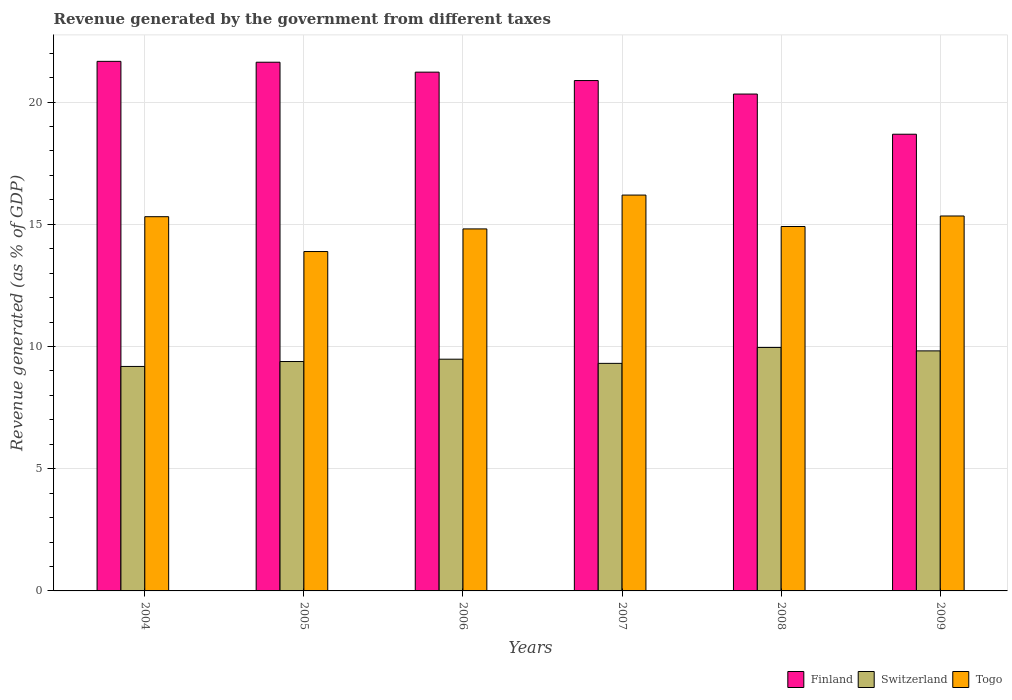How many different coloured bars are there?
Provide a short and direct response. 3. How many groups of bars are there?
Provide a short and direct response. 6. Are the number of bars per tick equal to the number of legend labels?
Your answer should be very brief. Yes. In how many cases, is the number of bars for a given year not equal to the number of legend labels?
Give a very brief answer. 0. What is the revenue generated by the government in Switzerland in 2008?
Offer a terse response. 9.96. Across all years, what is the maximum revenue generated by the government in Togo?
Make the answer very short. 16.2. Across all years, what is the minimum revenue generated by the government in Switzerland?
Your response must be concise. 9.18. What is the total revenue generated by the government in Togo in the graph?
Provide a succinct answer. 90.45. What is the difference between the revenue generated by the government in Togo in 2006 and that in 2009?
Make the answer very short. -0.53. What is the difference between the revenue generated by the government in Togo in 2007 and the revenue generated by the government in Finland in 2009?
Provide a short and direct response. -2.49. What is the average revenue generated by the government in Switzerland per year?
Provide a short and direct response. 9.52. In the year 2009, what is the difference between the revenue generated by the government in Finland and revenue generated by the government in Switzerland?
Ensure brevity in your answer.  8.86. What is the ratio of the revenue generated by the government in Togo in 2004 to that in 2006?
Offer a terse response. 1.03. Is the difference between the revenue generated by the government in Finland in 2008 and 2009 greater than the difference between the revenue generated by the government in Switzerland in 2008 and 2009?
Give a very brief answer. Yes. What is the difference between the highest and the second highest revenue generated by the government in Finland?
Give a very brief answer. 0.04. What is the difference between the highest and the lowest revenue generated by the government in Switzerland?
Give a very brief answer. 0.78. Is the sum of the revenue generated by the government in Togo in 2006 and 2007 greater than the maximum revenue generated by the government in Switzerland across all years?
Ensure brevity in your answer.  Yes. What does the 2nd bar from the left in 2004 represents?
Keep it short and to the point. Switzerland. What does the 1st bar from the right in 2007 represents?
Offer a very short reply. Togo. Are all the bars in the graph horizontal?
Offer a very short reply. No. Does the graph contain grids?
Keep it short and to the point. Yes. Where does the legend appear in the graph?
Your answer should be compact. Bottom right. How many legend labels are there?
Provide a short and direct response. 3. How are the legend labels stacked?
Keep it short and to the point. Horizontal. What is the title of the graph?
Your response must be concise. Revenue generated by the government from different taxes. What is the label or title of the X-axis?
Make the answer very short. Years. What is the label or title of the Y-axis?
Ensure brevity in your answer.  Revenue generated (as % of GDP). What is the Revenue generated (as % of GDP) of Finland in 2004?
Your response must be concise. 21.67. What is the Revenue generated (as % of GDP) in Switzerland in 2004?
Give a very brief answer. 9.18. What is the Revenue generated (as % of GDP) of Togo in 2004?
Offer a terse response. 15.31. What is the Revenue generated (as % of GDP) of Finland in 2005?
Give a very brief answer. 21.63. What is the Revenue generated (as % of GDP) in Switzerland in 2005?
Ensure brevity in your answer.  9.38. What is the Revenue generated (as % of GDP) in Togo in 2005?
Your response must be concise. 13.88. What is the Revenue generated (as % of GDP) in Finland in 2006?
Keep it short and to the point. 21.22. What is the Revenue generated (as % of GDP) of Switzerland in 2006?
Your response must be concise. 9.48. What is the Revenue generated (as % of GDP) in Togo in 2006?
Your answer should be compact. 14.81. What is the Revenue generated (as % of GDP) in Finland in 2007?
Offer a terse response. 20.88. What is the Revenue generated (as % of GDP) in Switzerland in 2007?
Ensure brevity in your answer.  9.31. What is the Revenue generated (as % of GDP) of Togo in 2007?
Provide a short and direct response. 16.2. What is the Revenue generated (as % of GDP) in Finland in 2008?
Keep it short and to the point. 20.33. What is the Revenue generated (as % of GDP) in Switzerland in 2008?
Your answer should be very brief. 9.96. What is the Revenue generated (as % of GDP) in Togo in 2008?
Ensure brevity in your answer.  14.91. What is the Revenue generated (as % of GDP) in Finland in 2009?
Make the answer very short. 18.68. What is the Revenue generated (as % of GDP) in Switzerland in 2009?
Your answer should be very brief. 9.82. What is the Revenue generated (as % of GDP) of Togo in 2009?
Your answer should be compact. 15.34. Across all years, what is the maximum Revenue generated (as % of GDP) in Finland?
Your response must be concise. 21.67. Across all years, what is the maximum Revenue generated (as % of GDP) of Switzerland?
Offer a very short reply. 9.96. Across all years, what is the maximum Revenue generated (as % of GDP) in Togo?
Provide a succinct answer. 16.2. Across all years, what is the minimum Revenue generated (as % of GDP) of Finland?
Keep it short and to the point. 18.68. Across all years, what is the minimum Revenue generated (as % of GDP) of Switzerland?
Offer a terse response. 9.18. Across all years, what is the minimum Revenue generated (as % of GDP) in Togo?
Provide a short and direct response. 13.88. What is the total Revenue generated (as % of GDP) in Finland in the graph?
Your response must be concise. 124.41. What is the total Revenue generated (as % of GDP) of Switzerland in the graph?
Provide a short and direct response. 57.14. What is the total Revenue generated (as % of GDP) of Togo in the graph?
Offer a very short reply. 90.45. What is the difference between the Revenue generated (as % of GDP) of Finland in 2004 and that in 2005?
Your answer should be compact. 0.04. What is the difference between the Revenue generated (as % of GDP) in Switzerland in 2004 and that in 2005?
Make the answer very short. -0.2. What is the difference between the Revenue generated (as % of GDP) in Togo in 2004 and that in 2005?
Provide a succinct answer. 1.43. What is the difference between the Revenue generated (as % of GDP) of Finland in 2004 and that in 2006?
Provide a short and direct response. 0.44. What is the difference between the Revenue generated (as % of GDP) in Switzerland in 2004 and that in 2006?
Your response must be concise. -0.3. What is the difference between the Revenue generated (as % of GDP) in Togo in 2004 and that in 2006?
Make the answer very short. 0.5. What is the difference between the Revenue generated (as % of GDP) in Finland in 2004 and that in 2007?
Your response must be concise. 0.79. What is the difference between the Revenue generated (as % of GDP) of Switzerland in 2004 and that in 2007?
Ensure brevity in your answer.  -0.13. What is the difference between the Revenue generated (as % of GDP) in Togo in 2004 and that in 2007?
Offer a terse response. -0.88. What is the difference between the Revenue generated (as % of GDP) of Finland in 2004 and that in 2008?
Make the answer very short. 1.34. What is the difference between the Revenue generated (as % of GDP) of Switzerland in 2004 and that in 2008?
Offer a terse response. -0.78. What is the difference between the Revenue generated (as % of GDP) of Togo in 2004 and that in 2008?
Provide a succinct answer. 0.4. What is the difference between the Revenue generated (as % of GDP) in Finland in 2004 and that in 2009?
Make the answer very short. 2.98. What is the difference between the Revenue generated (as % of GDP) of Switzerland in 2004 and that in 2009?
Give a very brief answer. -0.64. What is the difference between the Revenue generated (as % of GDP) of Togo in 2004 and that in 2009?
Make the answer very short. -0.03. What is the difference between the Revenue generated (as % of GDP) in Finland in 2005 and that in 2006?
Keep it short and to the point. 0.41. What is the difference between the Revenue generated (as % of GDP) in Switzerland in 2005 and that in 2006?
Your answer should be compact. -0.1. What is the difference between the Revenue generated (as % of GDP) of Togo in 2005 and that in 2006?
Offer a very short reply. -0.93. What is the difference between the Revenue generated (as % of GDP) of Finland in 2005 and that in 2007?
Provide a succinct answer. 0.75. What is the difference between the Revenue generated (as % of GDP) in Switzerland in 2005 and that in 2007?
Ensure brevity in your answer.  0.08. What is the difference between the Revenue generated (as % of GDP) of Togo in 2005 and that in 2007?
Your answer should be very brief. -2.31. What is the difference between the Revenue generated (as % of GDP) in Finland in 2005 and that in 2008?
Make the answer very short. 1.3. What is the difference between the Revenue generated (as % of GDP) in Switzerland in 2005 and that in 2008?
Keep it short and to the point. -0.58. What is the difference between the Revenue generated (as % of GDP) in Togo in 2005 and that in 2008?
Your answer should be very brief. -1.02. What is the difference between the Revenue generated (as % of GDP) in Finland in 2005 and that in 2009?
Your answer should be very brief. 2.95. What is the difference between the Revenue generated (as % of GDP) in Switzerland in 2005 and that in 2009?
Ensure brevity in your answer.  -0.44. What is the difference between the Revenue generated (as % of GDP) of Togo in 2005 and that in 2009?
Offer a very short reply. -1.45. What is the difference between the Revenue generated (as % of GDP) of Finland in 2006 and that in 2007?
Offer a very short reply. 0.34. What is the difference between the Revenue generated (as % of GDP) of Switzerland in 2006 and that in 2007?
Ensure brevity in your answer.  0.17. What is the difference between the Revenue generated (as % of GDP) in Togo in 2006 and that in 2007?
Provide a succinct answer. -1.38. What is the difference between the Revenue generated (as % of GDP) of Finland in 2006 and that in 2008?
Keep it short and to the point. 0.9. What is the difference between the Revenue generated (as % of GDP) of Switzerland in 2006 and that in 2008?
Your answer should be compact. -0.48. What is the difference between the Revenue generated (as % of GDP) in Togo in 2006 and that in 2008?
Provide a succinct answer. -0.1. What is the difference between the Revenue generated (as % of GDP) of Finland in 2006 and that in 2009?
Offer a terse response. 2.54. What is the difference between the Revenue generated (as % of GDP) in Switzerland in 2006 and that in 2009?
Keep it short and to the point. -0.34. What is the difference between the Revenue generated (as % of GDP) in Togo in 2006 and that in 2009?
Offer a very short reply. -0.53. What is the difference between the Revenue generated (as % of GDP) in Finland in 2007 and that in 2008?
Provide a short and direct response. 0.55. What is the difference between the Revenue generated (as % of GDP) of Switzerland in 2007 and that in 2008?
Your response must be concise. -0.65. What is the difference between the Revenue generated (as % of GDP) in Togo in 2007 and that in 2008?
Provide a short and direct response. 1.29. What is the difference between the Revenue generated (as % of GDP) of Finland in 2007 and that in 2009?
Your response must be concise. 2.2. What is the difference between the Revenue generated (as % of GDP) of Switzerland in 2007 and that in 2009?
Provide a succinct answer. -0.51. What is the difference between the Revenue generated (as % of GDP) in Togo in 2007 and that in 2009?
Offer a terse response. 0.86. What is the difference between the Revenue generated (as % of GDP) of Finland in 2008 and that in 2009?
Give a very brief answer. 1.64. What is the difference between the Revenue generated (as % of GDP) of Switzerland in 2008 and that in 2009?
Provide a short and direct response. 0.14. What is the difference between the Revenue generated (as % of GDP) in Togo in 2008 and that in 2009?
Ensure brevity in your answer.  -0.43. What is the difference between the Revenue generated (as % of GDP) of Finland in 2004 and the Revenue generated (as % of GDP) of Switzerland in 2005?
Ensure brevity in your answer.  12.28. What is the difference between the Revenue generated (as % of GDP) of Finland in 2004 and the Revenue generated (as % of GDP) of Togo in 2005?
Provide a succinct answer. 7.78. What is the difference between the Revenue generated (as % of GDP) of Switzerland in 2004 and the Revenue generated (as % of GDP) of Togo in 2005?
Offer a very short reply. -4.7. What is the difference between the Revenue generated (as % of GDP) in Finland in 2004 and the Revenue generated (as % of GDP) in Switzerland in 2006?
Ensure brevity in your answer.  12.19. What is the difference between the Revenue generated (as % of GDP) of Finland in 2004 and the Revenue generated (as % of GDP) of Togo in 2006?
Provide a succinct answer. 6.86. What is the difference between the Revenue generated (as % of GDP) in Switzerland in 2004 and the Revenue generated (as % of GDP) in Togo in 2006?
Make the answer very short. -5.63. What is the difference between the Revenue generated (as % of GDP) of Finland in 2004 and the Revenue generated (as % of GDP) of Switzerland in 2007?
Give a very brief answer. 12.36. What is the difference between the Revenue generated (as % of GDP) of Finland in 2004 and the Revenue generated (as % of GDP) of Togo in 2007?
Your answer should be very brief. 5.47. What is the difference between the Revenue generated (as % of GDP) in Switzerland in 2004 and the Revenue generated (as % of GDP) in Togo in 2007?
Offer a terse response. -7.01. What is the difference between the Revenue generated (as % of GDP) of Finland in 2004 and the Revenue generated (as % of GDP) of Switzerland in 2008?
Offer a very short reply. 11.71. What is the difference between the Revenue generated (as % of GDP) in Finland in 2004 and the Revenue generated (as % of GDP) in Togo in 2008?
Provide a succinct answer. 6.76. What is the difference between the Revenue generated (as % of GDP) in Switzerland in 2004 and the Revenue generated (as % of GDP) in Togo in 2008?
Provide a short and direct response. -5.72. What is the difference between the Revenue generated (as % of GDP) of Finland in 2004 and the Revenue generated (as % of GDP) of Switzerland in 2009?
Your response must be concise. 11.85. What is the difference between the Revenue generated (as % of GDP) in Finland in 2004 and the Revenue generated (as % of GDP) in Togo in 2009?
Your answer should be compact. 6.33. What is the difference between the Revenue generated (as % of GDP) of Switzerland in 2004 and the Revenue generated (as % of GDP) of Togo in 2009?
Offer a terse response. -6.15. What is the difference between the Revenue generated (as % of GDP) in Finland in 2005 and the Revenue generated (as % of GDP) in Switzerland in 2006?
Your answer should be compact. 12.15. What is the difference between the Revenue generated (as % of GDP) of Finland in 2005 and the Revenue generated (as % of GDP) of Togo in 2006?
Your answer should be compact. 6.82. What is the difference between the Revenue generated (as % of GDP) of Switzerland in 2005 and the Revenue generated (as % of GDP) of Togo in 2006?
Provide a short and direct response. -5.43. What is the difference between the Revenue generated (as % of GDP) of Finland in 2005 and the Revenue generated (as % of GDP) of Switzerland in 2007?
Make the answer very short. 12.32. What is the difference between the Revenue generated (as % of GDP) in Finland in 2005 and the Revenue generated (as % of GDP) in Togo in 2007?
Your answer should be compact. 5.43. What is the difference between the Revenue generated (as % of GDP) in Switzerland in 2005 and the Revenue generated (as % of GDP) in Togo in 2007?
Provide a short and direct response. -6.81. What is the difference between the Revenue generated (as % of GDP) of Finland in 2005 and the Revenue generated (as % of GDP) of Switzerland in 2008?
Offer a terse response. 11.67. What is the difference between the Revenue generated (as % of GDP) in Finland in 2005 and the Revenue generated (as % of GDP) in Togo in 2008?
Your answer should be compact. 6.72. What is the difference between the Revenue generated (as % of GDP) of Switzerland in 2005 and the Revenue generated (as % of GDP) of Togo in 2008?
Provide a succinct answer. -5.52. What is the difference between the Revenue generated (as % of GDP) in Finland in 2005 and the Revenue generated (as % of GDP) in Switzerland in 2009?
Ensure brevity in your answer.  11.81. What is the difference between the Revenue generated (as % of GDP) in Finland in 2005 and the Revenue generated (as % of GDP) in Togo in 2009?
Your answer should be compact. 6.29. What is the difference between the Revenue generated (as % of GDP) of Switzerland in 2005 and the Revenue generated (as % of GDP) of Togo in 2009?
Your answer should be compact. -5.95. What is the difference between the Revenue generated (as % of GDP) in Finland in 2006 and the Revenue generated (as % of GDP) in Switzerland in 2007?
Your answer should be compact. 11.91. What is the difference between the Revenue generated (as % of GDP) of Finland in 2006 and the Revenue generated (as % of GDP) of Togo in 2007?
Offer a very short reply. 5.03. What is the difference between the Revenue generated (as % of GDP) in Switzerland in 2006 and the Revenue generated (as % of GDP) in Togo in 2007?
Keep it short and to the point. -6.71. What is the difference between the Revenue generated (as % of GDP) in Finland in 2006 and the Revenue generated (as % of GDP) in Switzerland in 2008?
Offer a terse response. 11.26. What is the difference between the Revenue generated (as % of GDP) in Finland in 2006 and the Revenue generated (as % of GDP) in Togo in 2008?
Your answer should be compact. 6.32. What is the difference between the Revenue generated (as % of GDP) of Switzerland in 2006 and the Revenue generated (as % of GDP) of Togo in 2008?
Offer a very short reply. -5.43. What is the difference between the Revenue generated (as % of GDP) of Finland in 2006 and the Revenue generated (as % of GDP) of Switzerland in 2009?
Give a very brief answer. 11.4. What is the difference between the Revenue generated (as % of GDP) in Finland in 2006 and the Revenue generated (as % of GDP) in Togo in 2009?
Offer a very short reply. 5.89. What is the difference between the Revenue generated (as % of GDP) in Switzerland in 2006 and the Revenue generated (as % of GDP) in Togo in 2009?
Your answer should be compact. -5.86. What is the difference between the Revenue generated (as % of GDP) of Finland in 2007 and the Revenue generated (as % of GDP) of Switzerland in 2008?
Your response must be concise. 10.92. What is the difference between the Revenue generated (as % of GDP) of Finland in 2007 and the Revenue generated (as % of GDP) of Togo in 2008?
Make the answer very short. 5.97. What is the difference between the Revenue generated (as % of GDP) in Switzerland in 2007 and the Revenue generated (as % of GDP) in Togo in 2008?
Your answer should be compact. -5.6. What is the difference between the Revenue generated (as % of GDP) in Finland in 2007 and the Revenue generated (as % of GDP) in Switzerland in 2009?
Offer a very short reply. 11.06. What is the difference between the Revenue generated (as % of GDP) of Finland in 2007 and the Revenue generated (as % of GDP) of Togo in 2009?
Your answer should be compact. 5.54. What is the difference between the Revenue generated (as % of GDP) of Switzerland in 2007 and the Revenue generated (as % of GDP) of Togo in 2009?
Your answer should be compact. -6.03. What is the difference between the Revenue generated (as % of GDP) of Finland in 2008 and the Revenue generated (as % of GDP) of Switzerland in 2009?
Your answer should be compact. 10.51. What is the difference between the Revenue generated (as % of GDP) of Finland in 2008 and the Revenue generated (as % of GDP) of Togo in 2009?
Give a very brief answer. 4.99. What is the difference between the Revenue generated (as % of GDP) in Switzerland in 2008 and the Revenue generated (as % of GDP) in Togo in 2009?
Keep it short and to the point. -5.38. What is the average Revenue generated (as % of GDP) in Finland per year?
Provide a short and direct response. 20.74. What is the average Revenue generated (as % of GDP) in Switzerland per year?
Ensure brevity in your answer.  9.52. What is the average Revenue generated (as % of GDP) of Togo per year?
Your answer should be very brief. 15.07. In the year 2004, what is the difference between the Revenue generated (as % of GDP) in Finland and Revenue generated (as % of GDP) in Switzerland?
Provide a succinct answer. 12.48. In the year 2004, what is the difference between the Revenue generated (as % of GDP) of Finland and Revenue generated (as % of GDP) of Togo?
Keep it short and to the point. 6.36. In the year 2004, what is the difference between the Revenue generated (as % of GDP) of Switzerland and Revenue generated (as % of GDP) of Togo?
Offer a terse response. -6.13. In the year 2005, what is the difference between the Revenue generated (as % of GDP) of Finland and Revenue generated (as % of GDP) of Switzerland?
Ensure brevity in your answer.  12.25. In the year 2005, what is the difference between the Revenue generated (as % of GDP) of Finland and Revenue generated (as % of GDP) of Togo?
Provide a succinct answer. 7.75. In the year 2006, what is the difference between the Revenue generated (as % of GDP) of Finland and Revenue generated (as % of GDP) of Switzerland?
Your response must be concise. 11.74. In the year 2006, what is the difference between the Revenue generated (as % of GDP) in Finland and Revenue generated (as % of GDP) in Togo?
Make the answer very short. 6.41. In the year 2006, what is the difference between the Revenue generated (as % of GDP) in Switzerland and Revenue generated (as % of GDP) in Togo?
Your response must be concise. -5.33. In the year 2007, what is the difference between the Revenue generated (as % of GDP) in Finland and Revenue generated (as % of GDP) in Switzerland?
Your response must be concise. 11.57. In the year 2007, what is the difference between the Revenue generated (as % of GDP) of Finland and Revenue generated (as % of GDP) of Togo?
Your answer should be very brief. 4.69. In the year 2007, what is the difference between the Revenue generated (as % of GDP) of Switzerland and Revenue generated (as % of GDP) of Togo?
Your response must be concise. -6.89. In the year 2008, what is the difference between the Revenue generated (as % of GDP) of Finland and Revenue generated (as % of GDP) of Switzerland?
Your response must be concise. 10.37. In the year 2008, what is the difference between the Revenue generated (as % of GDP) of Finland and Revenue generated (as % of GDP) of Togo?
Your response must be concise. 5.42. In the year 2008, what is the difference between the Revenue generated (as % of GDP) in Switzerland and Revenue generated (as % of GDP) in Togo?
Make the answer very short. -4.95. In the year 2009, what is the difference between the Revenue generated (as % of GDP) of Finland and Revenue generated (as % of GDP) of Switzerland?
Make the answer very short. 8.86. In the year 2009, what is the difference between the Revenue generated (as % of GDP) of Finland and Revenue generated (as % of GDP) of Togo?
Offer a very short reply. 3.35. In the year 2009, what is the difference between the Revenue generated (as % of GDP) of Switzerland and Revenue generated (as % of GDP) of Togo?
Offer a very short reply. -5.52. What is the ratio of the Revenue generated (as % of GDP) in Finland in 2004 to that in 2005?
Ensure brevity in your answer.  1. What is the ratio of the Revenue generated (as % of GDP) of Switzerland in 2004 to that in 2005?
Offer a terse response. 0.98. What is the ratio of the Revenue generated (as % of GDP) of Togo in 2004 to that in 2005?
Ensure brevity in your answer.  1.1. What is the ratio of the Revenue generated (as % of GDP) in Finland in 2004 to that in 2006?
Offer a terse response. 1.02. What is the ratio of the Revenue generated (as % of GDP) of Switzerland in 2004 to that in 2006?
Provide a succinct answer. 0.97. What is the ratio of the Revenue generated (as % of GDP) of Togo in 2004 to that in 2006?
Keep it short and to the point. 1.03. What is the ratio of the Revenue generated (as % of GDP) of Finland in 2004 to that in 2007?
Keep it short and to the point. 1.04. What is the ratio of the Revenue generated (as % of GDP) of Switzerland in 2004 to that in 2007?
Your answer should be compact. 0.99. What is the ratio of the Revenue generated (as % of GDP) of Togo in 2004 to that in 2007?
Offer a very short reply. 0.95. What is the ratio of the Revenue generated (as % of GDP) in Finland in 2004 to that in 2008?
Provide a short and direct response. 1.07. What is the ratio of the Revenue generated (as % of GDP) of Switzerland in 2004 to that in 2008?
Your answer should be very brief. 0.92. What is the ratio of the Revenue generated (as % of GDP) in Togo in 2004 to that in 2008?
Ensure brevity in your answer.  1.03. What is the ratio of the Revenue generated (as % of GDP) of Finland in 2004 to that in 2009?
Keep it short and to the point. 1.16. What is the ratio of the Revenue generated (as % of GDP) of Switzerland in 2004 to that in 2009?
Your response must be concise. 0.94. What is the ratio of the Revenue generated (as % of GDP) in Togo in 2004 to that in 2009?
Offer a very short reply. 1. What is the ratio of the Revenue generated (as % of GDP) in Finland in 2005 to that in 2006?
Keep it short and to the point. 1.02. What is the ratio of the Revenue generated (as % of GDP) of Finland in 2005 to that in 2007?
Your response must be concise. 1.04. What is the ratio of the Revenue generated (as % of GDP) in Togo in 2005 to that in 2007?
Your answer should be compact. 0.86. What is the ratio of the Revenue generated (as % of GDP) in Finland in 2005 to that in 2008?
Give a very brief answer. 1.06. What is the ratio of the Revenue generated (as % of GDP) in Switzerland in 2005 to that in 2008?
Your response must be concise. 0.94. What is the ratio of the Revenue generated (as % of GDP) of Togo in 2005 to that in 2008?
Make the answer very short. 0.93. What is the ratio of the Revenue generated (as % of GDP) of Finland in 2005 to that in 2009?
Your answer should be very brief. 1.16. What is the ratio of the Revenue generated (as % of GDP) of Switzerland in 2005 to that in 2009?
Your answer should be very brief. 0.96. What is the ratio of the Revenue generated (as % of GDP) of Togo in 2005 to that in 2009?
Your response must be concise. 0.91. What is the ratio of the Revenue generated (as % of GDP) of Finland in 2006 to that in 2007?
Your response must be concise. 1.02. What is the ratio of the Revenue generated (as % of GDP) of Switzerland in 2006 to that in 2007?
Provide a succinct answer. 1.02. What is the ratio of the Revenue generated (as % of GDP) in Togo in 2006 to that in 2007?
Give a very brief answer. 0.91. What is the ratio of the Revenue generated (as % of GDP) in Finland in 2006 to that in 2008?
Your response must be concise. 1.04. What is the ratio of the Revenue generated (as % of GDP) of Switzerland in 2006 to that in 2008?
Provide a short and direct response. 0.95. What is the ratio of the Revenue generated (as % of GDP) of Finland in 2006 to that in 2009?
Your response must be concise. 1.14. What is the ratio of the Revenue generated (as % of GDP) of Switzerland in 2006 to that in 2009?
Provide a succinct answer. 0.97. What is the ratio of the Revenue generated (as % of GDP) of Togo in 2006 to that in 2009?
Offer a very short reply. 0.97. What is the ratio of the Revenue generated (as % of GDP) in Finland in 2007 to that in 2008?
Your answer should be very brief. 1.03. What is the ratio of the Revenue generated (as % of GDP) in Switzerland in 2007 to that in 2008?
Make the answer very short. 0.93. What is the ratio of the Revenue generated (as % of GDP) in Togo in 2007 to that in 2008?
Your response must be concise. 1.09. What is the ratio of the Revenue generated (as % of GDP) of Finland in 2007 to that in 2009?
Make the answer very short. 1.12. What is the ratio of the Revenue generated (as % of GDP) of Switzerland in 2007 to that in 2009?
Offer a terse response. 0.95. What is the ratio of the Revenue generated (as % of GDP) in Togo in 2007 to that in 2009?
Give a very brief answer. 1.06. What is the ratio of the Revenue generated (as % of GDP) of Finland in 2008 to that in 2009?
Offer a terse response. 1.09. What is the ratio of the Revenue generated (as % of GDP) in Switzerland in 2008 to that in 2009?
Offer a very short reply. 1.01. What is the difference between the highest and the second highest Revenue generated (as % of GDP) in Finland?
Provide a succinct answer. 0.04. What is the difference between the highest and the second highest Revenue generated (as % of GDP) of Switzerland?
Your answer should be compact. 0.14. What is the difference between the highest and the second highest Revenue generated (as % of GDP) of Togo?
Your answer should be very brief. 0.86. What is the difference between the highest and the lowest Revenue generated (as % of GDP) of Finland?
Give a very brief answer. 2.98. What is the difference between the highest and the lowest Revenue generated (as % of GDP) of Switzerland?
Ensure brevity in your answer.  0.78. What is the difference between the highest and the lowest Revenue generated (as % of GDP) of Togo?
Provide a succinct answer. 2.31. 